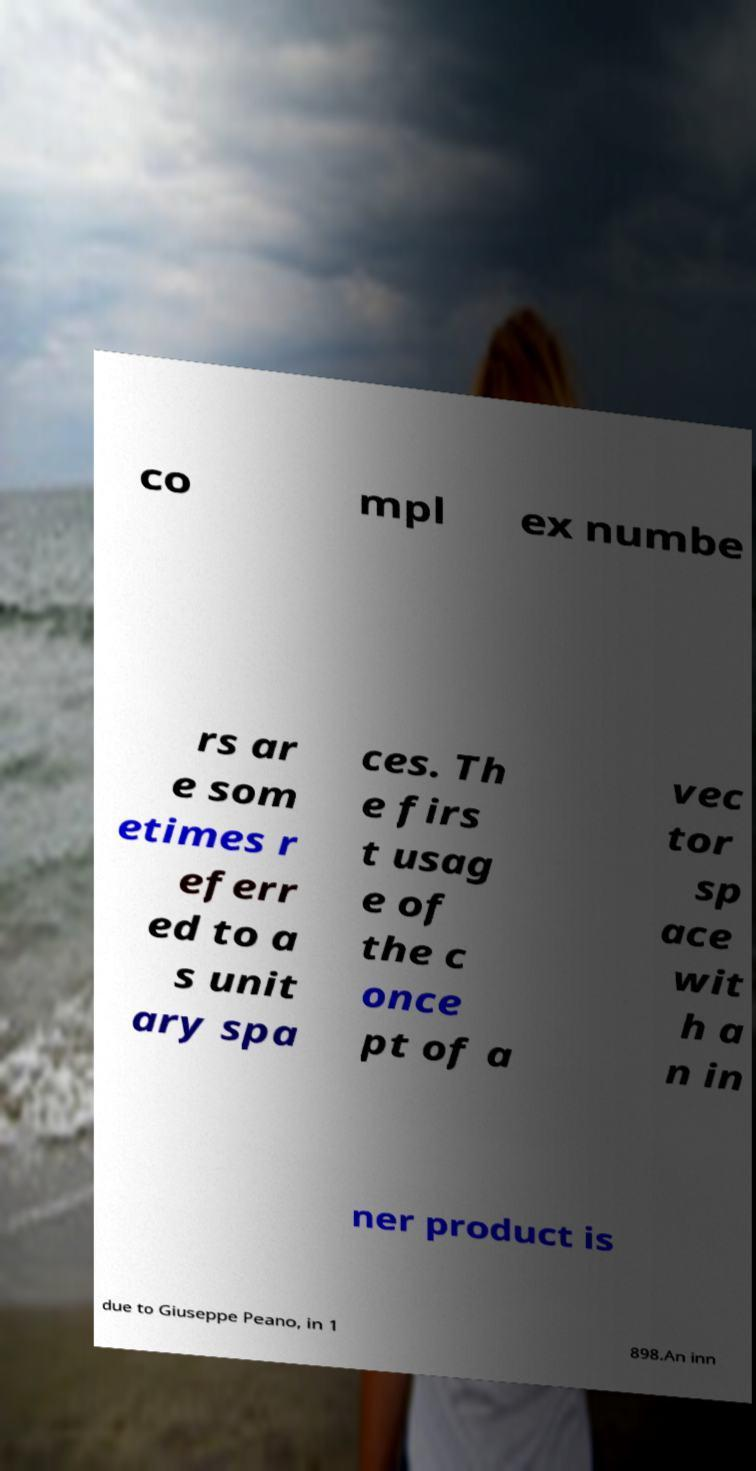I need the written content from this picture converted into text. Can you do that? co mpl ex numbe rs ar e som etimes r eferr ed to a s unit ary spa ces. Th e firs t usag e of the c once pt of a vec tor sp ace wit h a n in ner product is due to Giuseppe Peano, in 1 898.An inn 